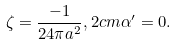Convert formula to latex. <formula><loc_0><loc_0><loc_500><loc_500>\zeta = \frac { - 1 } { 2 4 \pi a ^ { 2 } } , 2 c m \alpha ^ { \prime } = 0 .</formula> 